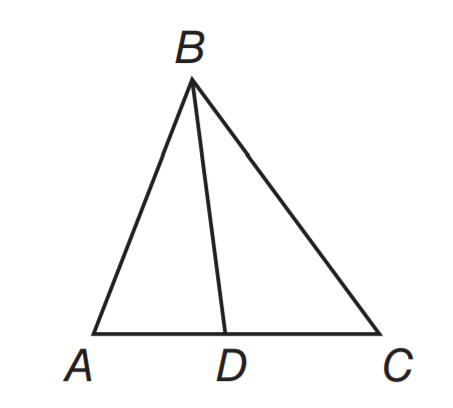Answer the mathemtical geometry problem and directly provide the correct option letter.
Question: In \triangle A B C, B D is a median. If A D = 3 x + 5 and C D = 5 x - 1, find A C.
Choices: A: 6 B: 12 C: 14 D: 28 D 